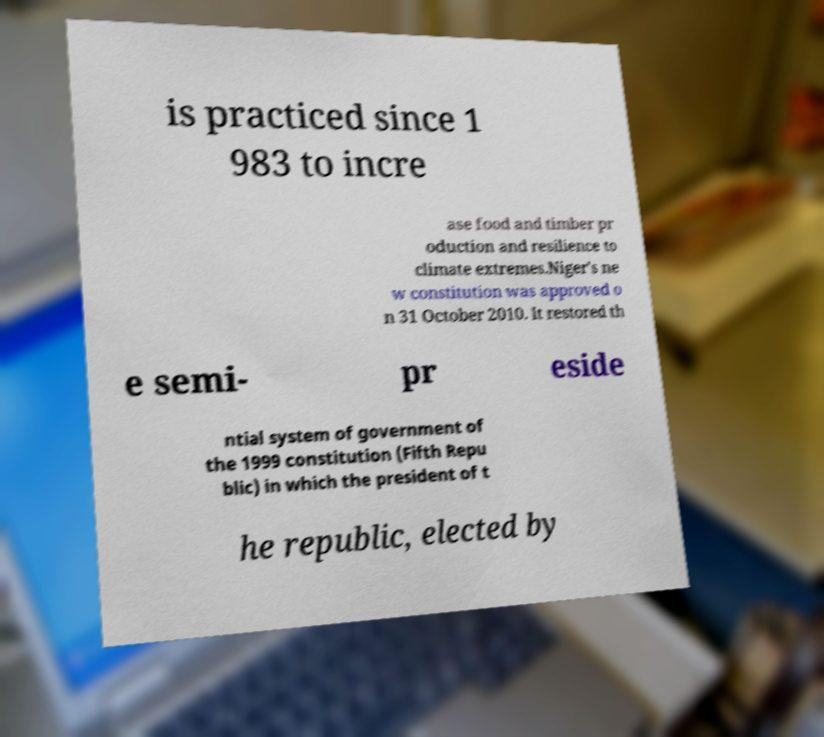Please read and relay the text visible in this image. What does it say? is practiced since 1 983 to incre ase food and timber pr oduction and resilience to climate extremes.Niger's ne w constitution was approved o n 31 October 2010. It restored th e semi- pr eside ntial system of government of the 1999 constitution (Fifth Repu blic) in which the president of t he republic, elected by 